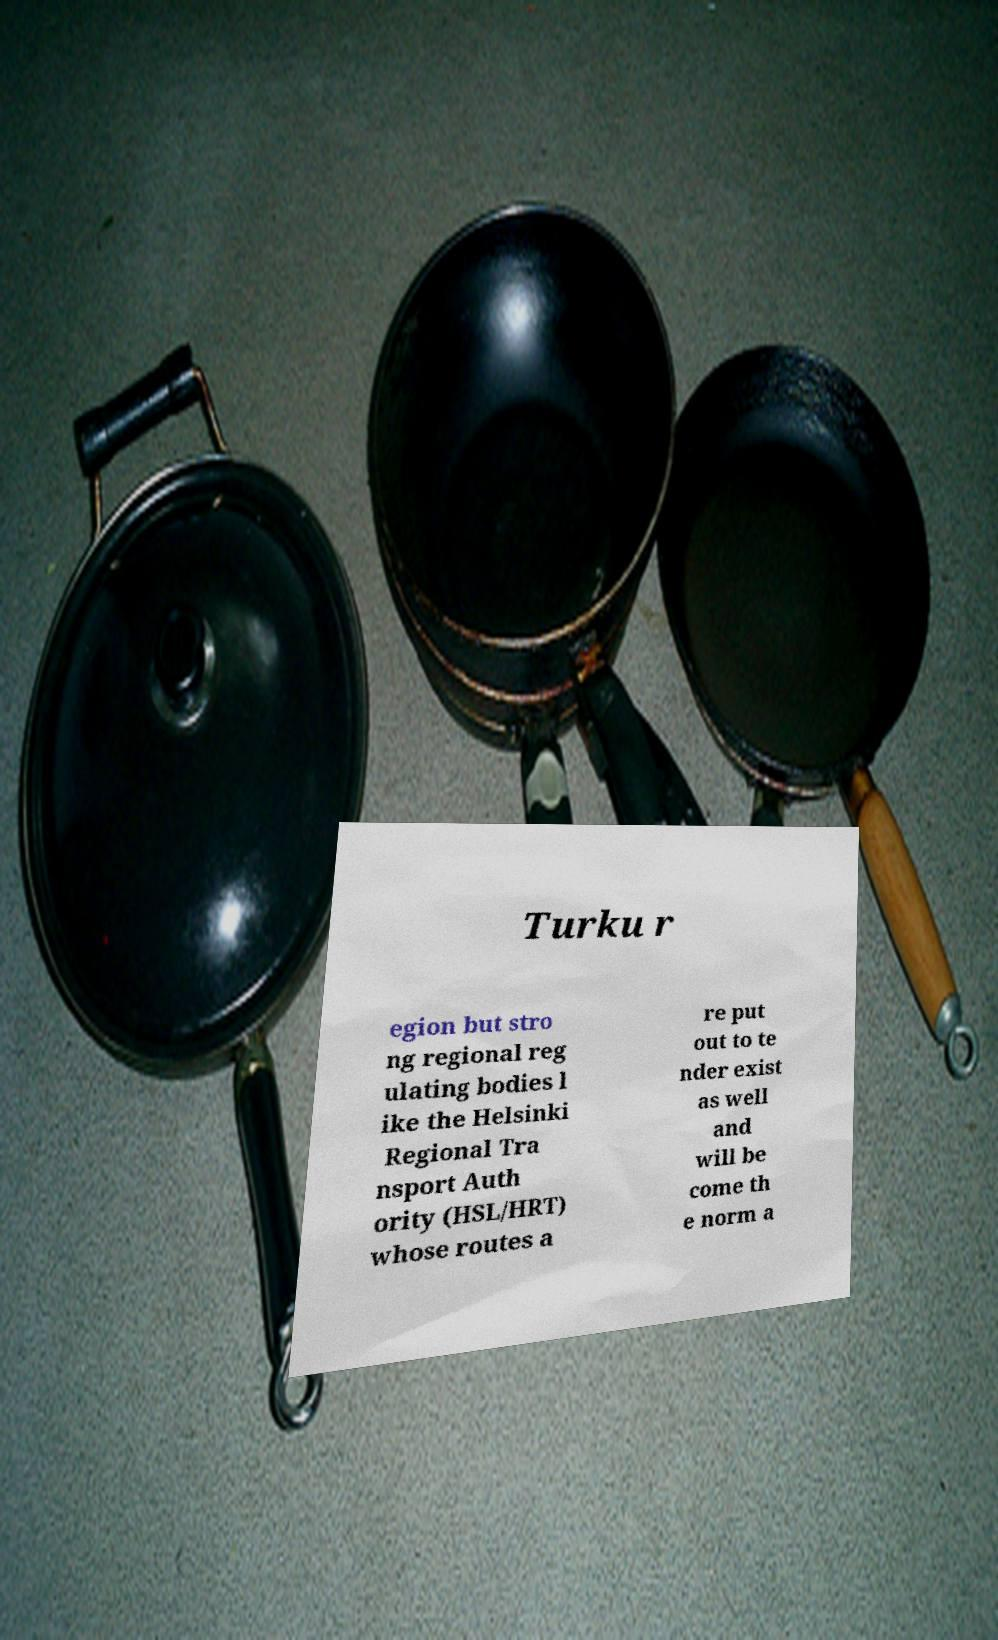Please read and relay the text visible in this image. What does it say? Turku r egion but stro ng regional reg ulating bodies l ike the Helsinki Regional Tra nsport Auth ority (HSL/HRT) whose routes a re put out to te nder exist as well and will be come th e norm a 